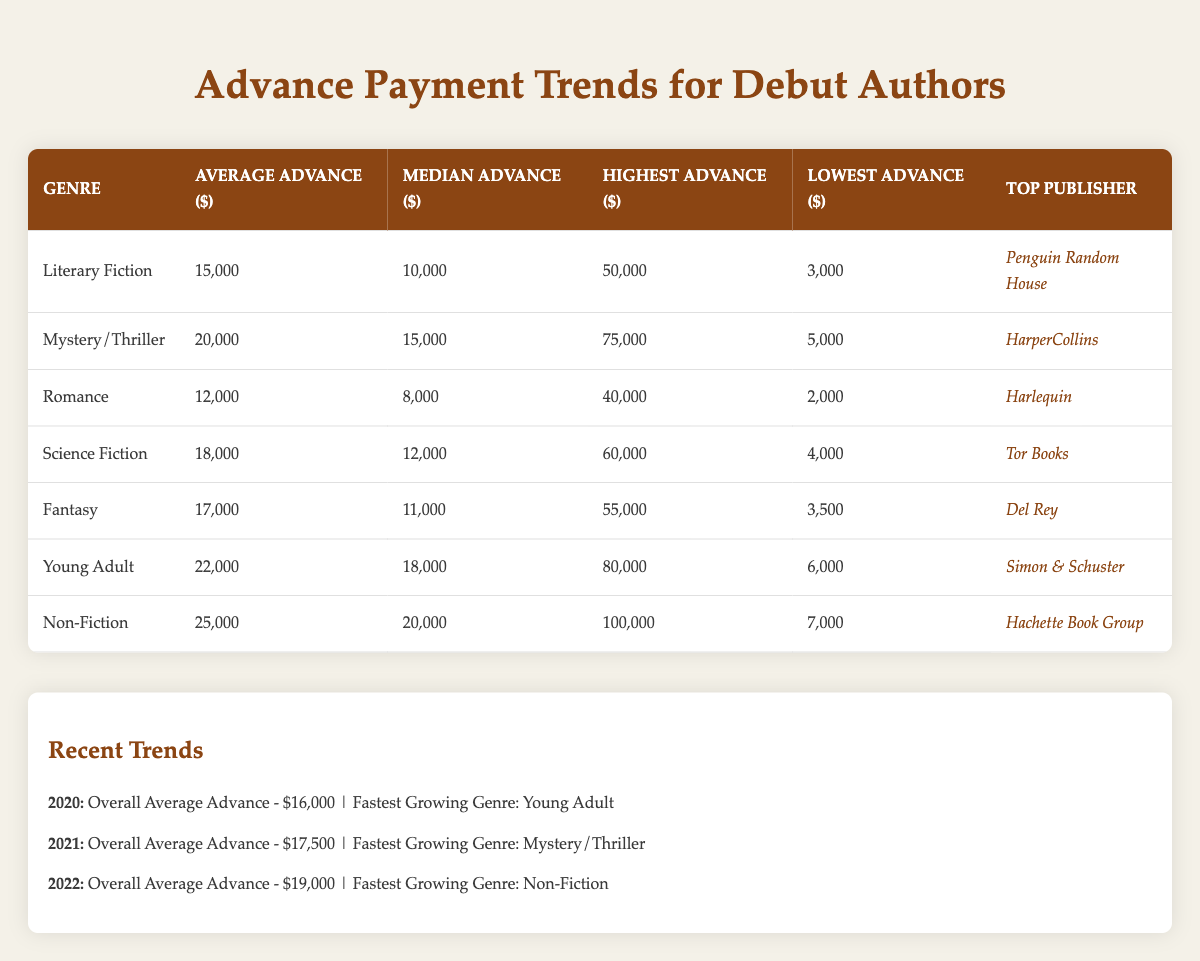What is the average advance for Non-Fiction debut authors? The table shows that the average advance for Non-Fiction is listed as 25,000.
Answer: 25,000 Which genre has the highest median advance? The table indicates the median advances for each genre. Non-Fiction has a median advance of 20,000, which is the highest among all genres.
Answer: Non-Fiction Is it true that the lowest advance for Young Adult is higher than the highest advance for Romance? The lowest advance for Young Adult is 6,000, and the highest advance for Romance is 40,000. Since 6,000 is lower, the statement is false.
Answer: False What is the difference between the highest advance in Mystery/Thriller and the lowest advance in Literary Fiction? The highest advance in Mystery/Thriller is 75,000, and the lowest advance in Literary Fiction is 3,000. The difference is 75,000 - 3,000 = 72,000.
Answer: 72,000 Which genre had the fastest growth in advance from 2020 to 2021? In 2021, the fastest-growing genre was Mystery/Thriller. In 2020, the fastest-growing genre was Young Adult. Comparing the two years shows that Mystery/Thriller was the fastest in 2021.
Answer: Mystery/Thriller What is the overall average advance for the year 2022? Looking at the trend data for 2022, the overall average advance is stated as 19,000.
Answer: 19,000 Which genre has the lowest average advance among all listed genres? Comparing the average advances in the table, Romance has the lowest average advance at 12,000.
Answer: Romance How does the average advance of Literary Fiction compare with that of Fantasy? Literary Fiction has an average advance of 15,000, while Fantasy has an average of 17,000. Fantasy has a higher average by 2,000.
Answer: Fantasy What is the trend in overall average advances from 2020 to 2022? The overall average advances increased from 16,000 in 2020 to 19,000 in 2022, showing an upward trend over these years.
Answer: Upward trend 